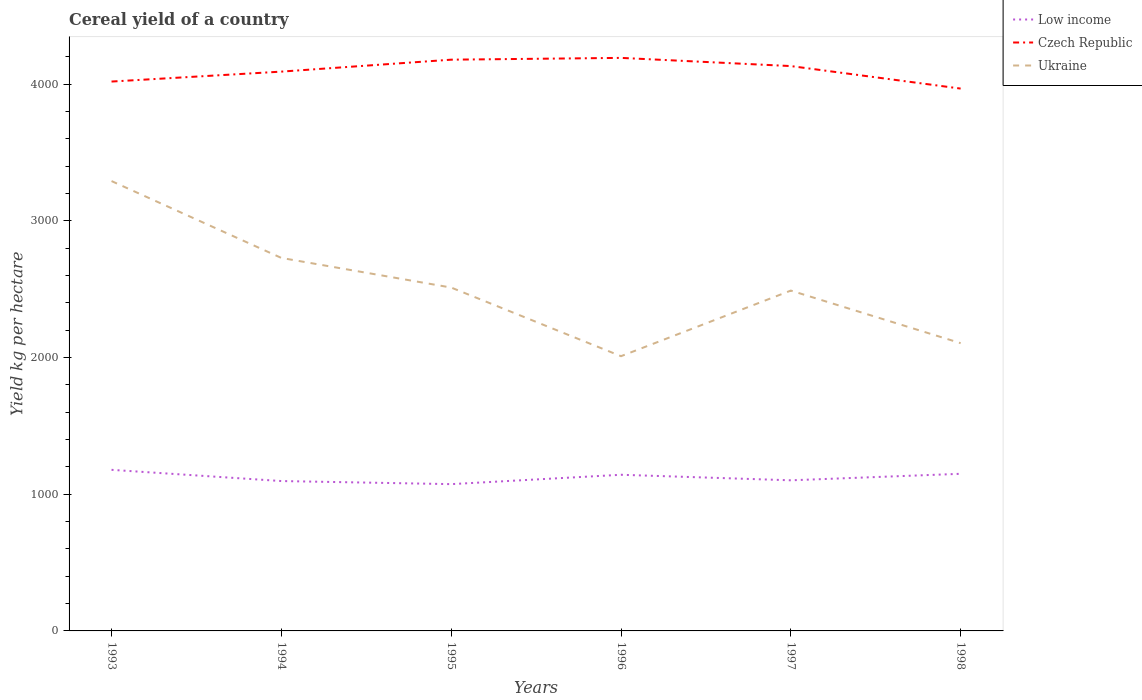How many different coloured lines are there?
Give a very brief answer. 3. Is the number of lines equal to the number of legend labels?
Make the answer very short. Yes. Across all years, what is the maximum total cereal yield in Ukraine?
Make the answer very short. 2010.14. What is the total total cereal yield in Low income in the graph?
Make the answer very short. 104.65. What is the difference between the highest and the second highest total cereal yield in Czech Republic?
Ensure brevity in your answer.  224.57. How many years are there in the graph?
Offer a very short reply. 6. Are the values on the major ticks of Y-axis written in scientific E-notation?
Keep it short and to the point. No. Does the graph contain any zero values?
Ensure brevity in your answer.  No. Where does the legend appear in the graph?
Offer a terse response. Top right. What is the title of the graph?
Offer a very short reply. Cereal yield of a country. Does "Zimbabwe" appear as one of the legend labels in the graph?
Your response must be concise. No. What is the label or title of the Y-axis?
Offer a very short reply. Yield kg per hectare. What is the Yield kg per hectare of Low income in 1993?
Keep it short and to the point. 1178.62. What is the Yield kg per hectare in Czech Republic in 1993?
Your answer should be very brief. 4019.52. What is the Yield kg per hectare in Ukraine in 1993?
Make the answer very short. 3291.35. What is the Yield kg per hectare of Low income in 1994?
Your response must be concise. 1096.58. What is the Yield kg per hectare in Czech Republic in 1994?
Keep it short and to the point. 4092.2. What is the Yield kg per hectare of Ukraine in 1994?
Provide a short and direct response. 2728.99. What is the Yield kg per hectare of Low income in 1995?
Offer a terse response. 1073.97. What is the Yield kg per hectare in Czech Republic in 1995?
Offer a terse response. 4179.58. What is the Yield kg per hectare in Ukraine in 1995?
Provide a succinct answer. 2512.29. What is the Yield kg per hectare in Low income in 1996?
Make the answer very short. 1142.5. What is the Yield kg per hectare of Czech Republic in 1996?
Provide a short and direct response. 4192.66. What is the Yield kg per hectare of Ukraine in 1996?
Offer a very short reply. 2010.14. What is the Yield kg per hectare in Low income in 1997?
Give a very brief answer. 1102.02. What is the Yield kg per hectare in Czech Republic in 1997?
Ensure brevity in your answer.  4132.77. What is the Yield kg per hectare in Ukraine in 1997?
Your answer should be very brief. 2490.11. What is the Yield kg per hectare of Low income in 1998?
Ensure brevity in your answer.  1149.62. What is the Yield kg per hectare of Czech Republic in 1998?
Offer a terse response. 3968.1. What is the Yield kg per hectare in Ukraine in 1998?
Offer a very short reply. 2105.38. Across all years, what is the maximum Yield kg per hectare of Low income?
Your answer should be compact. 1178.62. Across all years, what is the maximum Yield kg per hectare in Czech Republic?
Your response must be concise. 4192.66. Across all years, what is the maximum Yield kg per hectare of Ukraine?
Make the answer very short. 3291.35. Across all years, what is the minimum Yield kg per hectare in Low income?
Your response must be concise. 1073.97. Across all years, what is the minimum Yield kg per hectare of Czech Republic?
Your answer should be very brief. 3968.1. Across all years, what is the minimum Yield kg per hectare of Ukraine?
Make the answer very short. 2010.14. What is the total Yield kg per hectare of Low income in the graph?
Your answer should be compact. 6743.32. What is the total Yield kg per hectare of Czech Republic in the graph?
Make the answer very short. 2.46e+04. What is the total Yield kg per hectare in Ukraine in the graph?
Keep it short and to the point. 1.51e+04. What is the difference between the Yield kg per hectare in Low income in 1993 and that in 1994?
Offer a very short reply. 82.04. What is the difference between the Yield kg per hectare in Czech Republic in 1993 and that in 1994?
Your response must be concise. -72.68. What is the difference between the Yield kg per hectare in Ukraine in 1993 and that in 1994?
Provide a succinct answer. 562.36. What is the difference between the Yield kg per hectare in Low income in 1993 and that in 1995?
Give a very brief answer. 104.65. What is the difference between the Yield kg per hectare of Czech Republic in 1993 and that in 1995?
Ensure brevity in your answer.  -160.06. What is the difference between the Yield kg per hectare of Ukraine in 1993 and that in 1995?
Ensure brevity in your answer.  779.06. What is the difference between the Yield kg per hectare in Low income in 1993 and that in 1996?
Your answer should be compact. 36.12. What is the difference between the Yield kg per hectare of Czech Republic in 1993 and that in 1996?
Make the answer very short. -173.14. What is the difference between the Yield kg per hectare in Ukraine in 1993 and that in 1996?
Ensure brevity in your answer.  1281.21. What is the difference between the Yield kg per hectare of Low income in 1993 and that in 1997?
Provide a succinct answer. 76.6. What is the difference between the Yield kg per hectare of Czech Republic in 1993 and that in 1997?
Provide a short and direct response. -113.25. What is the difference between the Yield kg per hectare of Ukraine in 1993 and that in 1997?
Your answer should be very brief. 801.24. What is the difference between the Yield kg per hectare in Low income in 1993 and that in 1998?
Your response must be concise. 29. What is the difference between the Yield kg per hectare of Czech Republic in 1993 and that in 1998?
Make the answer very short. 51.42. What is the difference between the Yield kg per hectare of Ukraine in 1993 and that in 1998?
Provide a short and direct response. 1185.97. What is the difference between the Yield kg per hectare of Low income in 1994 and that in 1995?
Your answer should be very brief. 22.61. What is the difference between the Yield kg per hectare of Czech Republic in 1994 and that in 1995?
Ensure brevity in your answer.  -87.39. What is the difference between the Yield kg per hectare in Ukraine in 1994 and that in 1995?
Provide a succinct answer. 216.7. What is the difference between the Yield kg per hectare of Low income in 1994 and that in 1996?
Your response must be concise. -45.92. What is the difference between the Yield kg per hectare in Czech Republic in 1994 and that in 1996?
Provide a short and direct response. -100.47. What is the difference between the Yield kg per hectare in Ukraine in 1994 and that in 1996?
Ensure brevity in your answer.  718.85. What is the difference between the Yield kg per hectare in Low income in 1994 and that in 1997?
Provide a short and direct response. -5.44. What is the difference between the Yield kg per hectare of Czech Republic in 1994 and that in 1997?
Offer a terse response. -40.57. What is the difference between the Yield kg per hectare of Ukraine in 1994 and that in 1997?
Ensure brevity in your answer.  238.88. What is the difference between the Yield kg per hectare in Low income in 1994 and that in 1998?
Your answer should be very brief. -53.04. What is the difference between the Yield kg per hectare in Czech Republic in 1994 and that in 1998?
Offer a terse response. 124.1. What is the difference between the Yield kg per hectare of Ukraine in 1994 and that in 1998?
Provide a succinct answer. 623.6. What is the difference between the Yield kg per hectare in Low income in 1995 and that in 1996?
Give a very brief answer. -68.53. What is the difference between the Yield kg per hectare in Czech Republic in 1995 and that in 1996?
Provide a succinct answer. -13.08. What is the difference between the Yield kg per hectare in Ukraine in 1995 and that in 1996?
Offer a terse response. 502.15. What is the difference between the Yield kg per hectare in Low income in 1995 and that in 1997?
Ensure brevity in your answer.  -28.05. What is the difference between the Yield kg per hectare of Czech Republic in 1995 and that in 1997?
Provide a succinct answer. 46.81. What is the difference between the Yield kg per hectare of Ukraine in 1995 and that in 1997?
Ensure brevity in your answer.  22.18. What is the difference between the Yield kg per hectare in Low income in 1995 and that in 1998?
Offer a very short reply. -75.65. What is the difference between the Yield kg per hectare of Czech Republic in 1995 and that in 1998?
Offer a very short reply. 211.49. What is the difference between the Yield kg per hectare of Ukraine in 1995 and that in 1998?
Make the answer very short. 406.9. What is the difference between the Yield kg per hectare of Low income in 1996 and that in 1997?
Your answer should be compact. 40.48. What is the difference between the Yield kg per hectare in Czech Republic in 1996 and that in 1997?
Provide a succinct answer. 59.89. What is the difference between the Yield kg per hectare in Ukraine in 1996 and that in 1997?
Your answer should be very brief. -479.97. What is the difference between the Yield kg per hectare in Low income in 1996 and that in 1998?
Offer a terse response. -7.12. What is the difference between the Yield kg per hectare of Czech Republic in 1996 and that in 1998?
Ensure brevity in your answer.  224.56. What is the difference between the Yield kg per hectare in Ukraine in 1996 and that in 1998?
Give a very brief answer. -95.25. What is the difference between the Yield kg per hectare of Low income in 1997 and that in 1998?
Make the answer very short. -47.6. What is the difference between the Yield kg per hectare in Czech Republic in 1997 and that in 1998?
Provide a short and direct response. 164.67. What is the difference between the Yield kg per hectare of Ukraine in 1997 and that in 1998?
Offer a terse response. 384.72. What is the difference between the Yield kg per hectare of Low income in 1993 and the Yield kg per hectare of Czech Republic in 1994?
Provide a short and direct response. -2913.57. What is the difference between the Yield kg per hectare of Low income in 1993 and the Yield kg per hectare of Ukraine in 1994?
Your answer should be very brief. -1550.37. What is the difference between the Yield kg per hectare in Czech Republic in 1993 and the Yield kg per hectare in Ukraine in 1994?
Your answer should be very brief. 1290.53. What is the difference between the Yield kg per hectare of Low income in 1993 and the Yield kg per hectare of Czech Republic in 1995?
Provide a short and direct response. -3000.96. What is the difference between the Yield kg per hectare of Low income in 1993 and the Yield kg per hectare of Ukraine in 1995?
Offer a terse response. -1333.66. What is the difference between the Yield kg per hectare of Czech Republic in 1993 and the Yield kg per hectare of Ukraine in 1995?
Offer a terse response. 1507.23. What is the difference between the Yield kg per hectare of Low income in 1993 and the Yield kg per hectare of Czech Republic in 1996?
Provide a succinct answer. -3014.04. What is the difference between the Yield kg per hectare in Low income in 1993 and the Yield kg per hectare in Ukraine in 1996?
Your answer should be compact. -831.51. What is the difference between the Yield kg per hectare in Czech Republic in 1993 and the Yield kg per hectare in Ukraine in 1996?
Ensure brevity in your answer.  2009.38. What is the difference between the Yield kg per hectare of Low income in 1993 and the Yield kg per hectare of Czech Republic in 1997?
Make the answer very short. -2954.15. What is the difference between the Yield kg per hectare in Low income in 1993 and the Yield kg per hectare in Ukraine in 1997?
Provide a short and direct response. -1311.48. What is the difference between the Yield kg per hectare in Czech Republic in 1993 and the Yield kg per hectare in Ukraine in 1997?
Offer a very short reply. 1529.41. What is the difference between the Yield kg per hectare of Low income in 1993 and the Yield kg per hectare of Czech Republic in 1998?
Offer a terse response. -2789.47. What is the difference between the Yield kg per hectare in Low income in 1993 and the Yield kg per hectare in Ukraine in 1998?
Keep it short and to the point. -926.76. What is the difference between the Yield kg per hectare in Czech Republic in 1993 and the Yield kg per hectare in Ukraine in 1998?
Keep it short and to the point. 1914.13. What is the difference between the Yield kg per hectare in Low income in 1994 and the Yield kg per hectare in Czech Republic in 1995?
Make the answer very short. -3083. What is the difference between the Yield kg per hectare of Low income in 1994 and the Yield kg per hectare of Ukraine in 1995?
Offer a terse response. -1415.71. What is the difference between the Yield kg per hectare of Czech Republic in 1994 and the Yield kg per hectare of Ukraine in 1995?
Your response must be concise. 1579.91. What is the difference between the Yield kg per hectare of Low income in 1994 and the Yield kg per hectare of Czech Republic in 1996?
Offer a terse response. -3096.08. What is the difference between the Yield kg per hectare in Low income in 1994 and the Yield kg per hectare in Ukraine in 1996?
Offer a terse response. -913.56. What is the difference between the Yield kg per hectare in Czech Republic in 1994 and the Yield kg per hectare in Ukraine in 1996?
Your answer should be very brief. 2082.06. What is the difference between the Yield kg per hectare of Low income in 1994 and the Yield kg per hectare of Czech Republic in 1997?
Offer a terse response. -3036.19. What is the difference between the Yield kg per hectare in Low income in 1994 and the Yield kg per hectare in Ukraine in 1997?
Provide a short and direct response. -1393.53. What is the difference between the Yield kg per hectare of Czech Republic in 1994 and the Yield kg per hectare of Ukraine in 1997?
Provide a succinct answer. 1602.09. What is the difference between the Yield kg per hectare of Low income in 1994 and the Yield kg per hectare of Czech Republic in 1998?
Ensure brevity in your answer.  -2871.52. What is the difference between the Yield kg per hectare of Low income in 1994 and the Yield kg per hectare of Ukraine in 1998?
Your answer should be very brief. -1008.8. What is the difference between the Yield kg per hectare of Czech Republic in 1994 and the Yield kg per hectare of Ukraine in 1998?
Offer a terse response. 1986.81. What is the difference between the Yield kg per hectare in Low income in 1995 and the Yield kg per hectare in Czech Republic in 1996?
Provide a short and direct response. -3118.69. What is the difference between the Yield kg per hectare of Low income in 1995 and the Yield kg per hectare of Ukraine in 1996?
Make the answer very short. -936.16. What is the difference between the Yield kg per hectare of Czech Republic in 1995 and the Yield kg per hectare of Ukraine in 1996?
Keep it short and to the point. 2169.45. What is the difference between the Yield kg per hectare in Low income in 1995 and the Yield kg per hectare in Czech Republic in 1997?
Your answer should be compact. -3058.79. What is the difference between the Yield kg per hectare of Low income in 1995 and the Yield kg per hectare of Ukraine in 1997?
Your response must be concise. -1416.13. What is the difference between the Yield kg per hectare of Czech Republic in 1995 and the Yield kg per hectare of Ukraine in 1997?
Provide a succinct answer. 1689.48. What is the difference between the Yield kg per hectare in Low income in 1995 and the Yield kg per hectare in Czech Republic in 1998?
Keep it short and to the point. -2894.12. What is the difference between the Yield kg per hectare of Low income in 1995 and the Yield kg per hectare of Ukraine in 1998?
Ensure brevity in your answer.  -1031.41. What is the difference between the Yield kg per hectare of Czech Republic in 1995 and the Yield kg per hectare of Ukraine in 1998?
Give a very brief answer. 2074.2. What is the difference between the Yield kg per hectare of Low income in 1996 and the Yield kg per hectare of Czech Republic in 1997?
Make the answer very short. -2990.27. What is the difference between the Yield kg per hectare in Low income in 1996 and the Yield kg per hectare in Ukraine in 1997?
Offer a very short reply. -1347.6. What is the difference between the Yield kg per hectare of Czech Republic in 1996 and the Yield kg per hectare of Ukraine in 1997?
Ensure brevity in your answer.  1702.56. What is the difference between the Yield kg per hectare in Low income in 1996 and the Yield kg per hectare in Czech Republic in 1998?
Your response must be concise. -2825.59. What is the difference between the Yield kg per hectare of Low income in 1996 and the Yield kg per hectare of Ukraine in 1998?
Your answer should be compact. -962.88. What is the difference between the Yield kg per hectare in Czech Republic in 1996 and the Yield kg per hectare in Ukraine in 1998?
Your answer should be very brief. 2087.28. What is the difference between the Yield kg per hectare in Low income in 1997 and the Yield kg per hectare in Czech Republic in 1998?
Ensure brevity in your answer.  -2866.07. What is the difference between the Yield kg per hectare in Low income in 1997 and the Yield kg per hectare in Ukraine in 1998?
Keep it short and to the point. -1003.36. What is the difference between the Yield kg per hectare in Czech Republic in 1997 and the Yield kg per hectare in Ukraine in 1998?
Your answer should be very brief. 2027.38. What is the average Yield kg per hectare in Low income per year?
Give a very brief answer. 1123.89. What is the average Yield kg per hectare in Czech Republic per year?
Your response must be concise. 4097.47. What is the average Yield kg per hectare of Ukraine per year?
Your response must be concise. 2523.04. In the year 1993, what is the difference between the Yield kg per hectare in Low income and Yield kg per hectare in Czech Republic?
Offer a terse response. -2840.9. In the year 1993, what is the difference between the Yield kg per hectare of Low income and Yield kg per hectare of Ukraine?
Make the answer very short. -2112.73. In the year 1993, what is the difference between the Yield kg per hectare in Czech Republic and Yield kg per hectare in Ukraine?
Provide a short and direct response. 728.17. In the year 1994, what is the difference between the Yield kg per hectare of Low income and Yield kg per hectare of Czech Republic?
Give a very brief answer. -2995.61. In the year 1994, what is the difference between the Yield kg per hectare of Low income and Yield kg per hectare of Ukraine?
Your answer should be very brief. -1632.41. In the year 1994, what is the difference between the Yield kg per hectare in Czech Republic and Yield kg per hectare in Ukraine?
Keep it short and to the point. 1363.21. In the year 1995, what is the difference between the Yield kg per hectare of Low income and Yield kg per hectare of Czech Republic?
Ensure brevity in your answer.  -3105.61. In the year 1995, what is the difference between the Yield kg per hectare in Low income and Yield kg per hectare in Ukraine?
Ensure brevity in your answer.  -1438.31. In the year 1995, what is the difference between the Yield kg per hectare of Czech Republic and Yield kg per hectare of Ukraine?
Give a very brief answer. 1667.3. In the year 1996, what is the difference between the Yield kg per hectare of Low income and Yield kg per hectare of Czech Republic?
Ensure brevity in your answer.  -3050.16. In the year 1996, what is the difference between the Yield kg per hectare of Low income and Yield kg per hectare of Ukraine?
Provide a succinct answer. -867.64. In the year 1996, what is the difference between the Yield kg per hectare of Czech Republic and Yield kg per hectare of Ukraine?
Offer a terse response. 2182.52. In the year 1997, what is the difference between the Yield kg per hectare in Low income and Yield kg per hectare in Czech Republic?
Keep it short and to the point. -3030.74. In the year 1997, what is the difference between the Yield kg per hectare in Low income and Yield kg per hectare in Ukraine?
Provide a succinct answer. -1388.08. In the year 1997, what is the difference between the Yield kg per hectare of Czech Republic and Yield kg per hectare of Ukraine?
Your answer should be compact. 1642.66. In the year 1998, what is the difference between the Yield kg per hectare of Low income and Yield kg per hectare of Czech Republic?
Keep it short and to the point. -2818.48. In the year 1998, what is the difference between the Yield kg per hectare in Low income and Yield kg per hectare in Ukraine?
Make the answer very short. -955.76. In the year 1998, what is the difference between the Yield kg per hectare in Czech Republic and Yield kg per hectare in Ukraine?
Give a very brief answer. 1862.71. What is the ratio of the Yield kg per hectare in Low income in 1993 to that in 1994?
Ensure brevity in your answer.  1.07. What is the ratio of the Yield kg per hectare of Czech Republic in 1993 to that in 1994?
Your answer should be very brief. 0.98. What is the ratio of the Yield kg per hectare of Ukraine in 1993 to that in 1994?
Offer a very short reply. 1.21. What is the ratio of the Yield kg per hectare in Low income in 1993 to that in 1995?
Your answer should be very brief. 1.1. What is the ratio of the Yield kg per hectare of Czech Republic in 1993 to that in 1995?
Offer a terse response. 0.96. What is the ratio of the Yield kg per hectare in Ukraine in 1993 to that in 1995?
Provide a short and direct response. 1.31. What is the ratio of the Yield kg per hectare in Low income in 1993 to that in 1996?
Provide a short and direct response. 1.03. What is the ratio of the Yield kg per hectare of Czech Republic in 1993 to that in 1996?
Make the answer very short. 0.96. What is the ratio of the Yield kg per hectare of Ukraine in 1993 to that in 1996?
Provide a short and direct response. 1.64. What is the ratio of the Yield kg per hectare in Low income in 1993 to that in 1997?
Your response must be concise. 1.07. What is the ratio of the Yield kg per hectare of Czech Republic in 1993 to that in 1997?
Your answer should be very brief. 0.97. What is the ratio of the Yield kg per hectare of Ukraine in 1993 to that in 1997?
Provide a succinct answer. 1.32. What is the ratio of the Yield kg per hectare of Low income in 1993 to that in 1998?
Make the answer very short. 1.03. What is the ratio of the Yield kg per hectare in Czech Republic in 1993 to that in 1998?
Ensure brevity in your answer.  1.01. What is the ratio of the Yield kg per hectare of Ukraine in 1993 to that in 1998?
Provide a short and direct response. 1.56. What is the ratio of the Yield kg per hectare of Czech Republic in 1994 to that in 1995?
Keep it short and to the point. 0.98. What is the ratio of the Yield kg per hectare of Ukraine in 1994 to that in 1995?
Your answer should be very brief. 1.09. What is the ratio of the Yield kg per hectare in Low income in 1994 to that in 1996?
Your answer should be compact. 0.96. What is the ratio of the Yield kg per hectare in Czech Republic in 1994 to that in 1996?
Keep it short and to the point. 0.98. What is the ratio of the Yield kg per hectare of Ukraine in 1994 to that in 1996?
Keep it short and to the point. 1.36. What is the ratio of the Yield kg per hectare in Czech Republic in 1994 to that in 1997?
Your response must be concise. 0.99. What is the ratio of the Yield kg per hectare in Ukraine in 1994 to that in 1997?
Provide a short and direct response. 1.1. What is the ratio of the Yield kg per hectare in Low income in 1994 to that in 1998?
Provide a succinct answer. 0.95. What is the ratio of the Yield kg per hectare in Czech Republic in 1994 to that in 1998?
Keep it short and to the point. 1.03. What is the ratio of the Yield kg per hectare of Ukraine in 1994 to that in 1998?
Make the answer very short. 1.3. What is the ratio of the Yield kg per hectare in Low income in 1995 to that in 1996?
Provide a succinct answer. 0.94. What is the ratio of the Yield kg per hectare in Ukraine in 1995 to that in 1996?
Ensure brevity in your answer.  1.25. What is the ratio of the Yield kg per hectare of Low income in 1995 to that in 1997?
Provide a short and direct response. 0.97. What is the ratio of the Yield kg per hectare of Czech Republic in 1995 to that in 1997?
Give a very brief answer. 1.01. What is the ratio of the Yield kg per hectare of Ukraine in 1995 to that in 1997?
Provide a succinct answer. 1.01. What is the ratio of the Yield kg per hectare of Low income in 1995 to that in 1998?
Keep it short and to the point. 0.93. What is the ratio of the Yield kg per hectare of Czech Republic in 1995 to that in 1998?
Keep it short and to the point. 1.05. What is the ratio of the Yield kg per hectare of Ukraine in 1995 to that in 1998?
Your answer should be very brief. 1.19. What is the ratio of the Yield kg per hectare of Low income in 1996 to that in 1997?
Your response must be concise. 1.04. What is the ratio of the Yield kg per hectare in Czech Republic in 1996 to that in 1997?
Provide a short and direct response. 1.01. What is the ratio of the Yield kg per hectare in Ukraine in 1996 to that in 1997?
Make the answer very short. 0.81. What is the ratio of the Yield kg per hectare in Czech Republic in 1996 to that in 1998?
Your answer should be compact. 1.06. What is the ratio of the Yield kg per hectare of Ukraine in 1996 to that in 1998?
Offer a terse response. 0.95. What is the ratio of the Yield kg per hectare in Low income in 1997 to that in 1998?
Keep it short and to the point. 0.96. What is the ratio of the Yield kg per hectare of Czech Republic in 1997 to that in 1998?
Keep it short and to the point. 1.04. What is the ratio of the Yield kg per hectare of Ukraine in 1997 to that in 1998?
Provide a short and direct response. 1.18. What is the difference between the highest and the second highest Yield kg per hectare of Low income?
Offer a terse response. 29. What is the difference between the highest and the second highest Yield kg per hectare in Czech Republic?
Offer a very short reply. 13.08. What is the difference between the highest and the second highest Yield kg per hectare of Ukraine?
Your answer should be compact. 562.36. What is the difference between the highest and the lowest Yield kg per hectare of Low income?
Make the answer very short. 104.65. What is the difference between the highest and the lowest Yield kg per hectare in Czech Republic?
Make the answer very short. 224.56. What is the difference between the highest and the lowest Yield kg per hectare in Ukraine?
Offer a very short reply. 1281.21. 